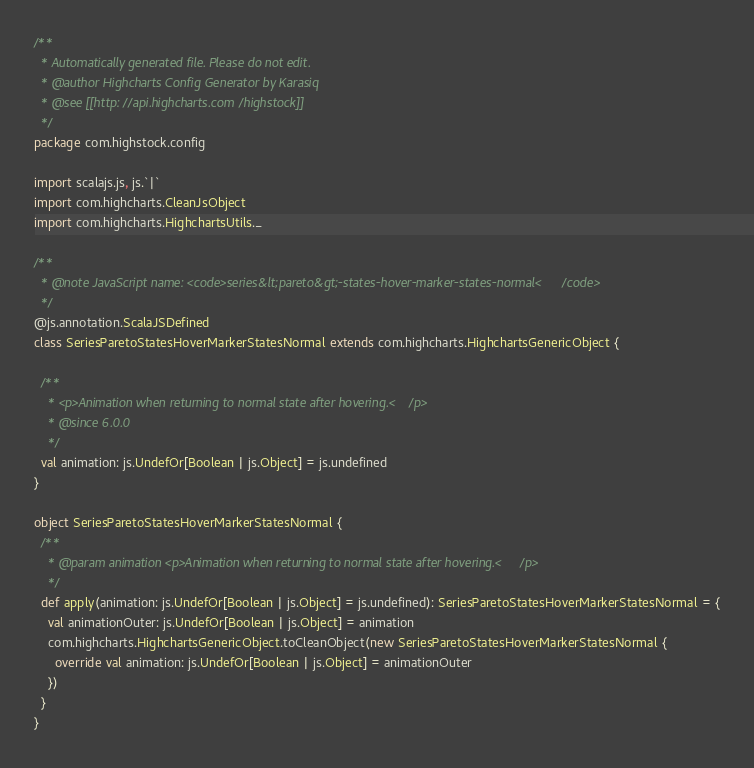Convert code to text. <code><loc_0><loc_0><loc_500><loc_500><_Scala_>/**
  * Automatically generated file. Please do not edit.
  * @author Highcharts Config Generator by Karasiq
  * @see [[http://api.highcharts.com/highstock]]
  */
package com.highstock.config

import scalajs.js, js.`|`
import com.highcharts.CleanJsObject
import com.highcharts.HighchartsUtils._

/**
  * @note JavaScript name: <code>series&lt;pareto&gt;-states-hover-marker-states-normal</code>
  */
@js.annotation.ScalaJSDefined
class SeriesParetoStatesHoverMarkerStatesNormal extends com.highcharts.HighchartsGenericObject {

  /**
    * <p>Animation when returning to normal state after hovering.</p>
    * @since 6.0.0
    */
  val animation: js.UndefOr[Boolean | js.Object] = js.undefined
}

object SeriesParetoStatesHoverMarkerStatesNormal {
  /**
    * @param animation <p>Animation when returning to normal state after hovering.</p>
    */
  def apply(animation: js.UndefOr[Boolean | js.Object] = js.undefined): SeriesParetoStatesHoverMarkerStatesNormal = {
    val animationOuter: js.UndefOr[Boolean | js.Object] = animation
    com.highcharts.HighchartsGenericObject.toCleanObject(new SeriesParetoStatesHoverMarkerStatesNormal {
      override val animation: js.UndefOr[Boolean | js.Object] = animationOuter
    })
  }
}
</code> 